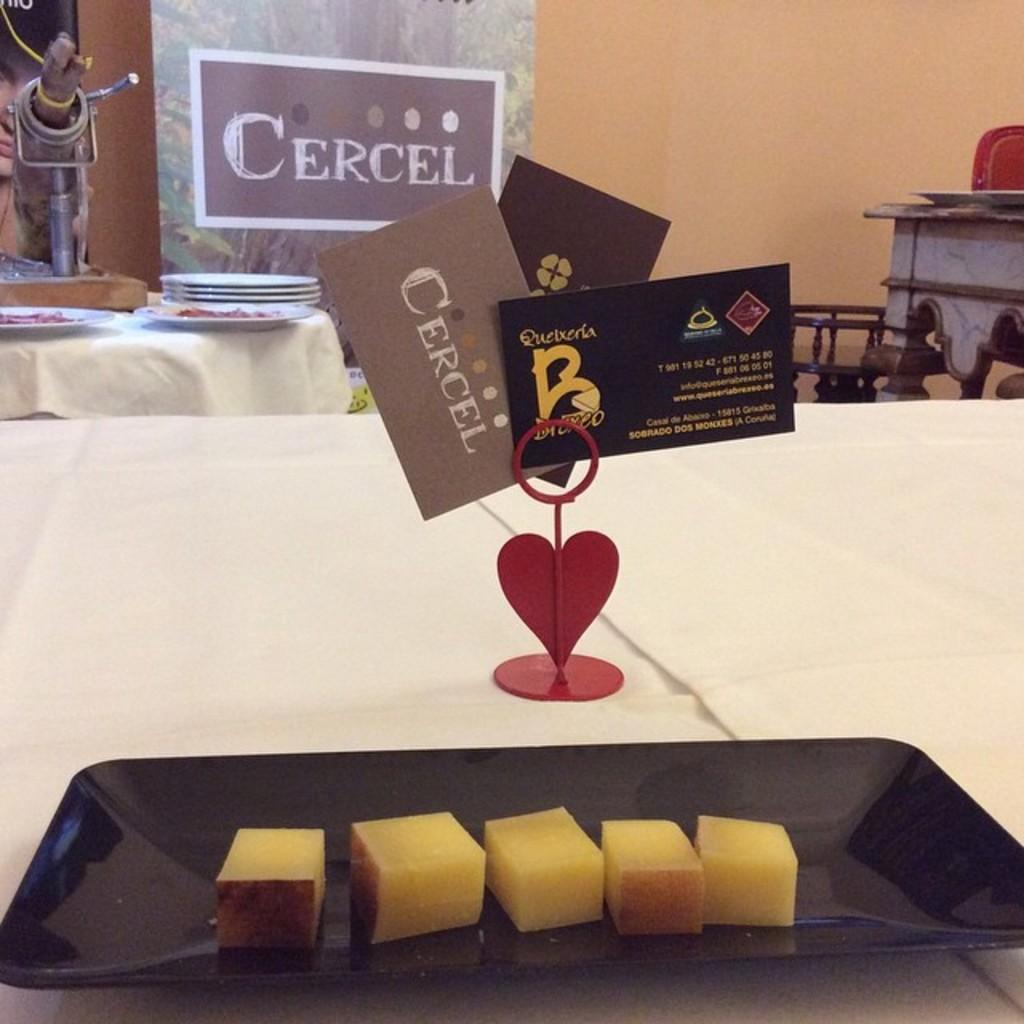In one or two sentences, can you explain what this image depicts? In this picture I can see a food item on the plate, there are cards with a stand on the table, there are plates and some items on the another table, there are banners and some other objects, and in the background there is a wall. 